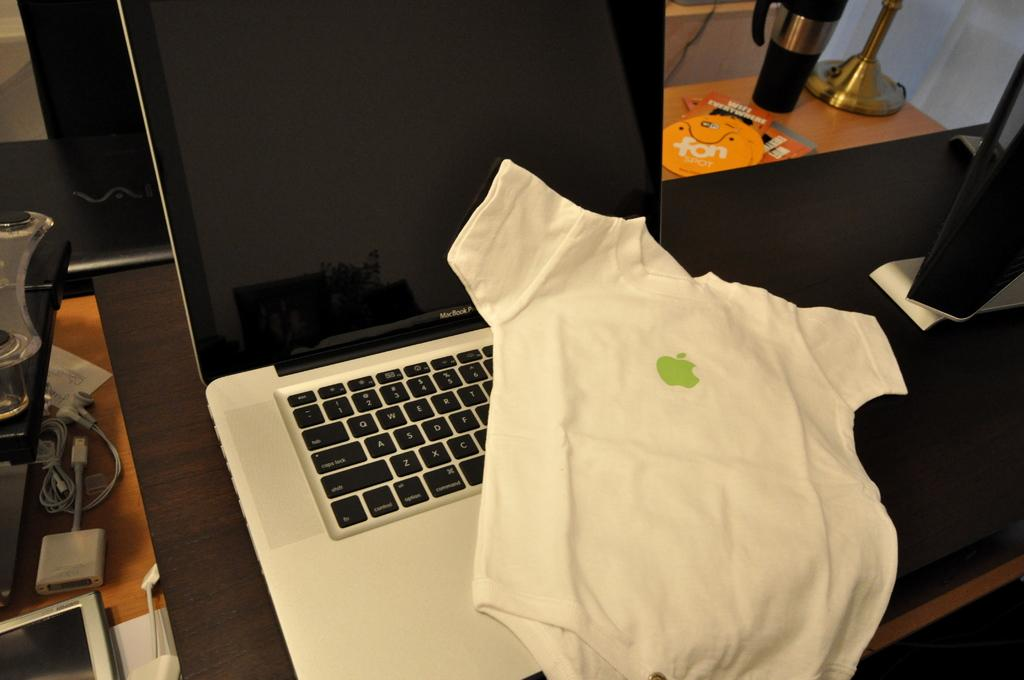What electronic device is visible in the image? There is a laptop in the image. What type of clothing item is present in the image? There is a small shirt in the image. Where are the laptop and shirt located? Both the laptop and the shirt are on a table. What items related to the laptop can be seen in the image? There are cables and CDs visible in the image. What other objects are on the table? There is a flask and papers in the image. What type of vegetable is being used as a paperweight in the image? There is no vegetable present in the image, let alone being used as a paperweight. 